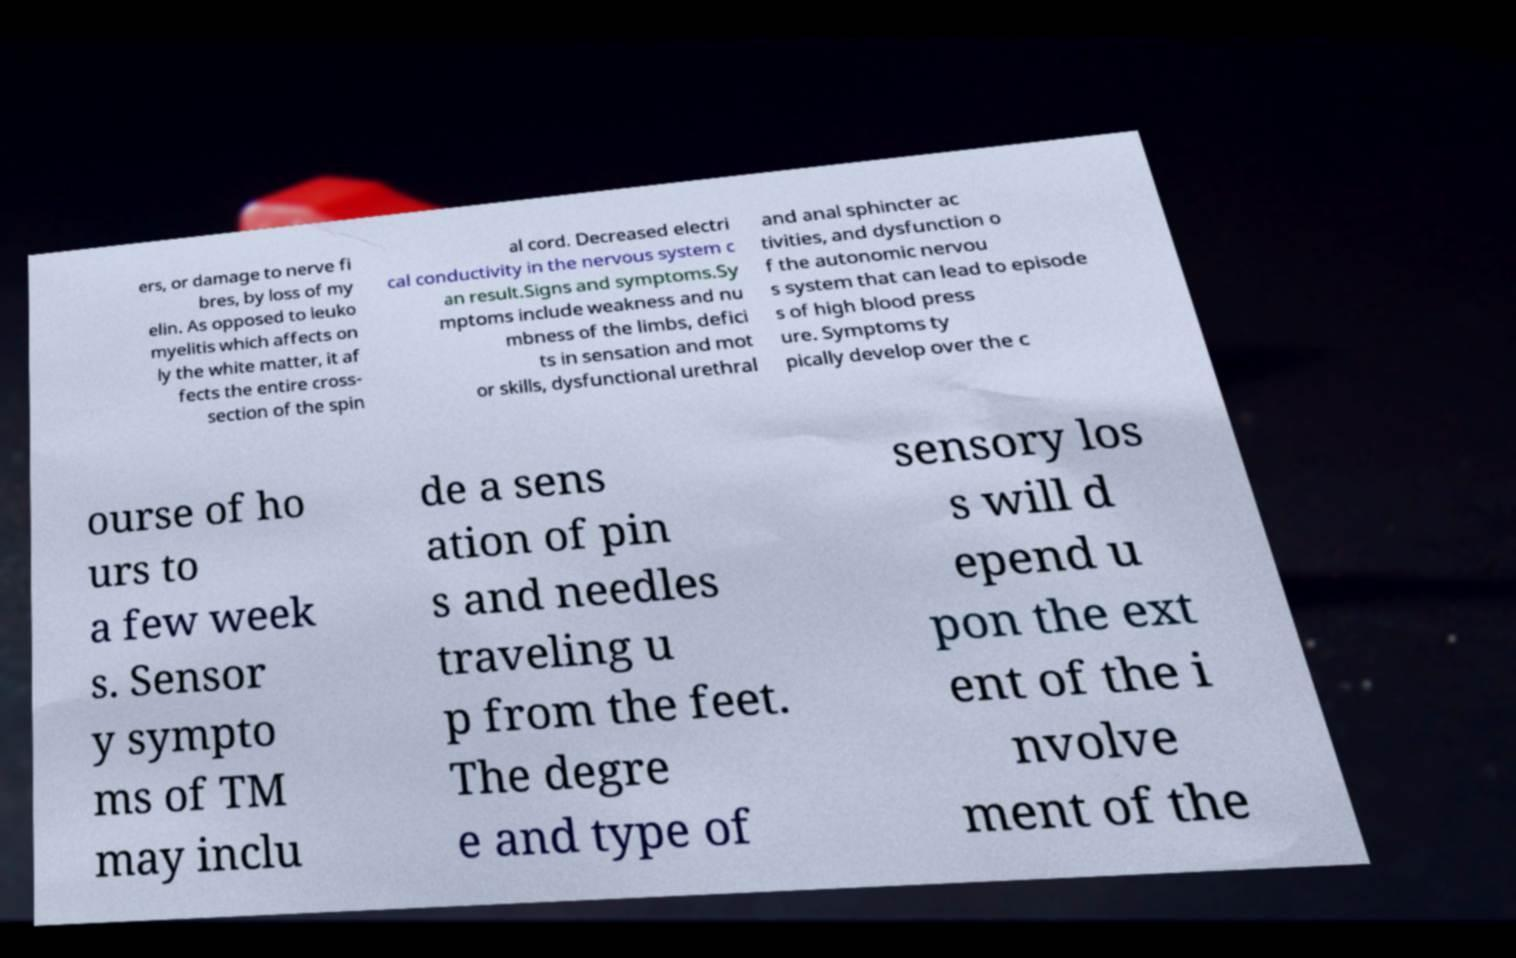Could you extract and type out the text from this image? ers, or damage to nerve fi bres, by loss of my elin. As opposed to leuko myelitis which affects on ly the white matter, it af fects the entire cross- section of the spin al cord. Decreased electri cal conductivity in the nervous system c an result.Signs and symptoms.Sy mptoms include weakness and nu mbness of the limbs, defici ts in sensation and mot or skills, dysfunctional urethral and anal sphincter ac tivities, and dysfunction o f the autonomic nervou s system that can lead to episode s of high blood press ure. Symptoms ty pically develop over the c ourse of ho urs to a few week s. Sensor y sympto ms of TM may inclu de a sens ation of pin s and needles traveling u p from the feet. The degre e and type of sensory los s will d epend u pon the ext ent of the i nvolve ment of the 